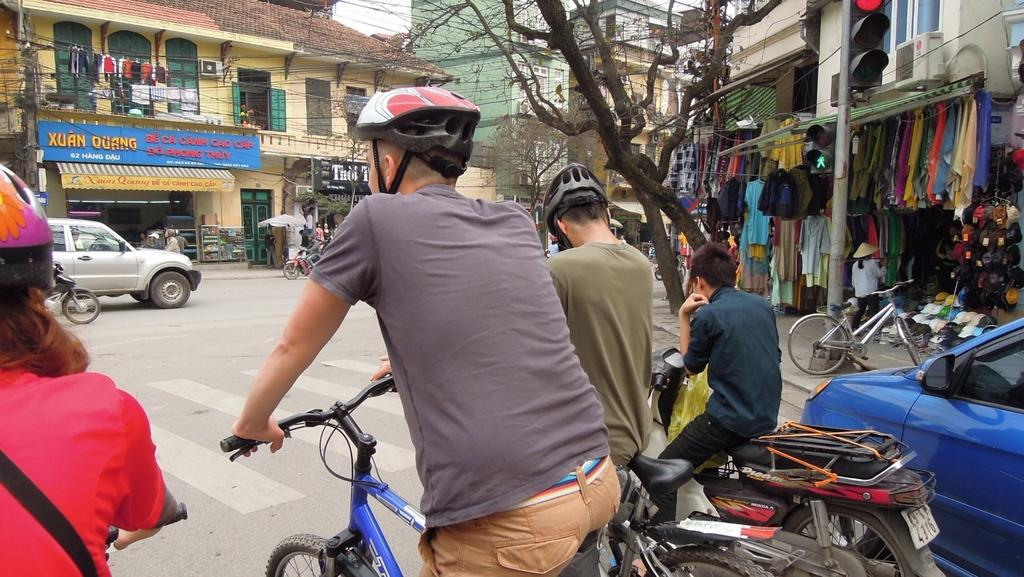What are the people in the image using for transportation? There are people on bikes and bicycles in the image. Where is the image taken? The image is taken on a road. What type of activity is happening on the pavement? There are vendors selling clothes on the pavement. What can be seen in the background of the image? There are buildings in front of the scene. How many babies are playing in the yard in the image? There is no yard or babies present in the image. What type of men can be seen working in the image? There is no reference to men or their work in the image. 